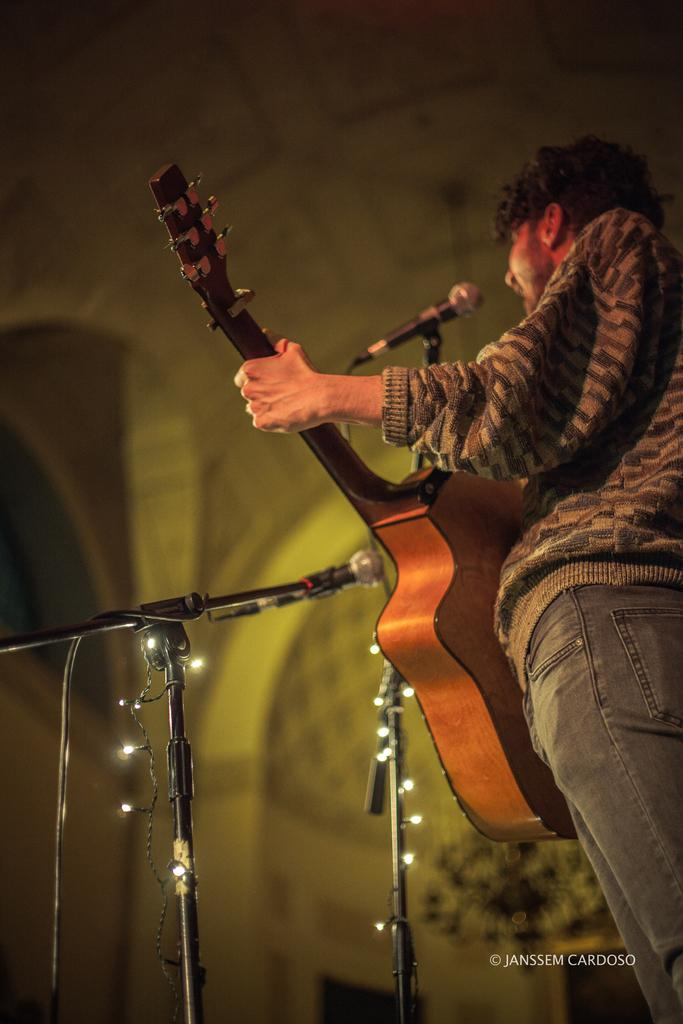What is the person in the image holding? The person is holding a guitar. What object is present in the image that is typically used for amplifying sound? There is a microphone in the image. What type of furniture or equipment is visible in the image? There is a stand in the image. What type of ice can be seen melting on the person's guitar in the image? There is no ice present in the image, and the person's guitar is not melting. 